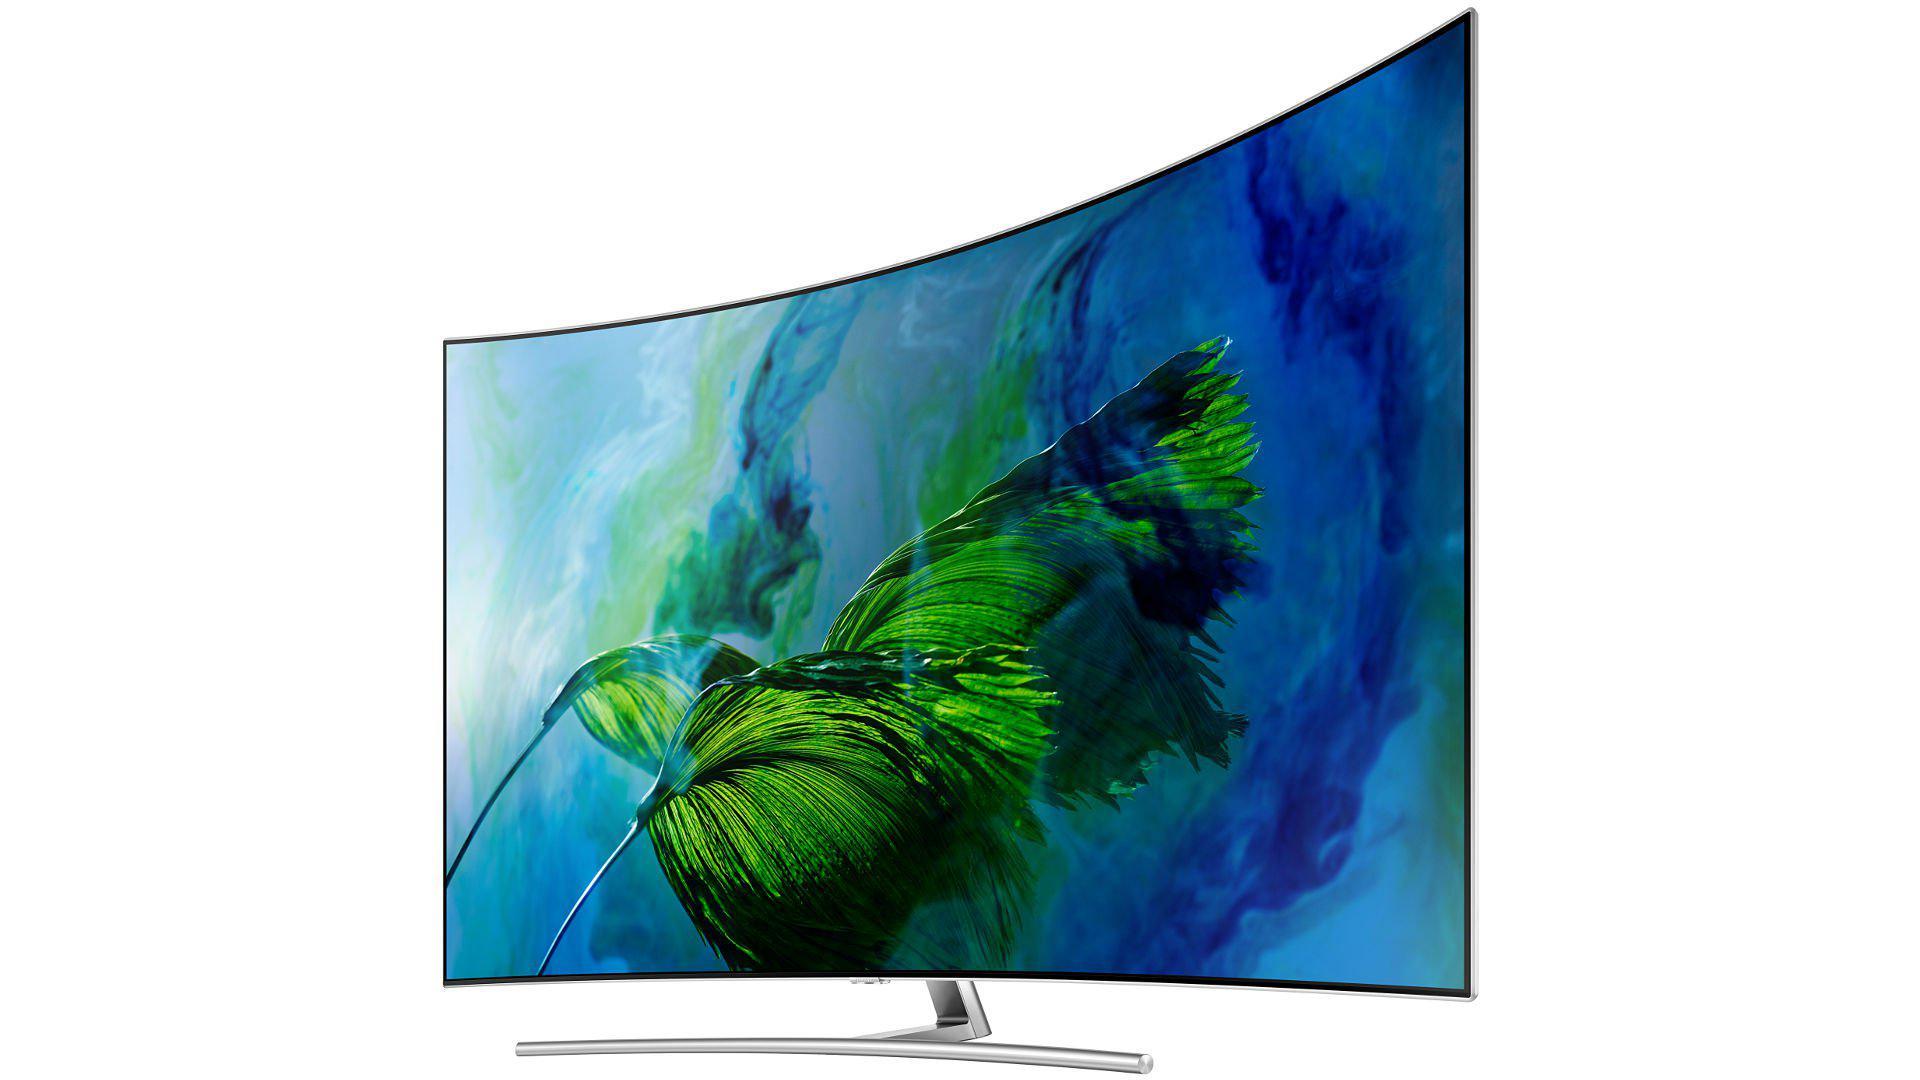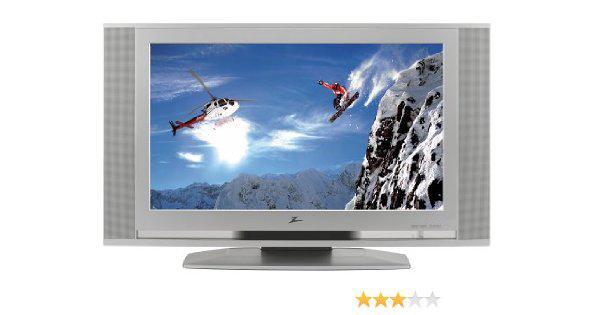The first image is the image on the left, the second image is the image on the right. Evaluate the accuracy of this statement regarding the images: "One screen is flat and viewed head-on, and the other screen is curved and displayed at an angle.". Is it true? Answer yes or no. Yes. The first image is the image on the left, the second image is the image on the right. For the images shown, is this caption "The left and right image contains the same number television with at least one curved television." true? Answer yes or no. Yes. 